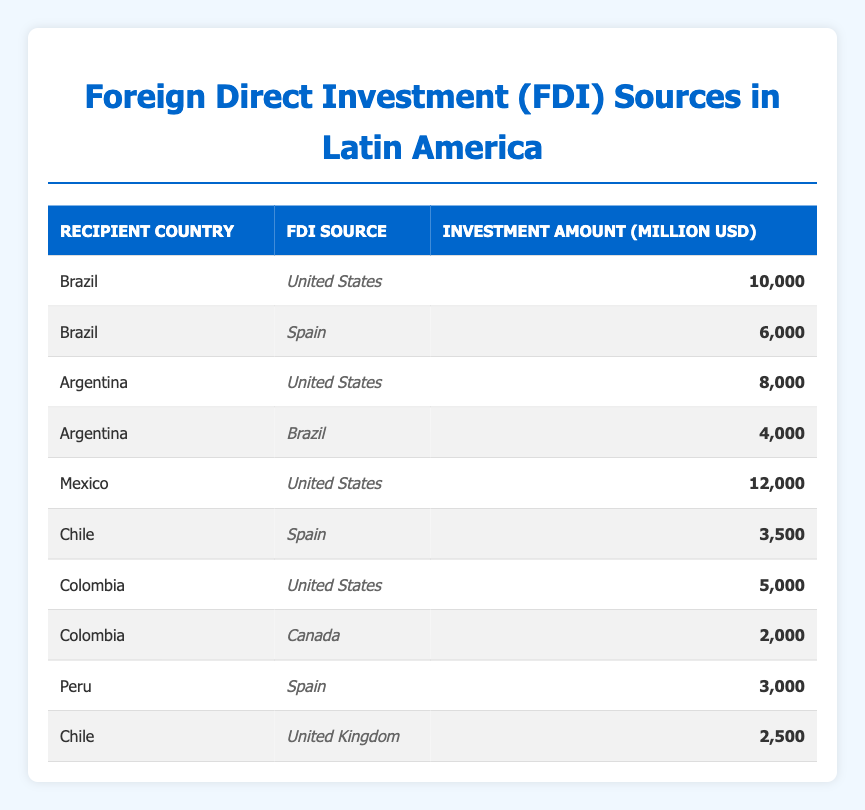What is the total foreign direct investment amount from the United States to Brazil? From the table, we can find the investment amount from the United States to Brazil, which is 10,000 million USD.
Answer: 10,000 million USD Which country received the highest foreign direct investment amount from the United States? The table shows the investment amounts to different countries from the United States. Comparing these, Mexico received the highest amount at 12,000 million USD.
Answer: Mexico How much total investment did Spain contribute to Chile and Peru combined? From the table, Spain invested 3,500 million USD in Chile and 3,000 million USD in Peru. Adding these amounts gives us 3,500 + 3,000 = 6,500 million USD.
Answer: 6,500 million USD Is Canada a source of foreign direct investment for Colombia? Looking at the table, Canada is listed as an FDI source for Colombia with an investment amount of 2,000 million USD. Therefore, the answer is yes.
Answer: Yes What is the average foreign direct investment amount from all sources to Argentina? The total FDI to Argentina comes from the United States (8,000 million USD) and Brazil (4,000 million USD). Adding these gives 8,000 + 4,000 = 12,000 million USD. As there are 2 sources, the average is 12,000 / 2 = 6,000 million USD.
Answer: 6,000 million USD Which country has the least foreign direct investment received, and what is that amount? In the table, Colombia receives 2,000 million USD from Canada, which is the lowest investment amount listed.
Answer: 2,000 million USD How much more foreign direct investment did Mexico receive compared to Argentina? Mexico received 12,000 million USD while Argentina received 12,000 million USD. Calculating the difference gives us 12,000 - 8,000 = 4,000 million USD more for Mexico.
Answer: 4,000 million USD Did Spain invest more in Brazil or in Peru? The table shows that Spain invested 6,000 million USD in Brazil and 3,000 million USD in Peru. Comparing these amounts, Spain invested more in Brazil.
Answer: Yes How many countries have United States as a source of foreign direct investment? Looking at the table, the countries that received investment from the United States are Brazil, Argentina, Mexico, and Colombia. This totals to 4 countries.
Answer: 4 